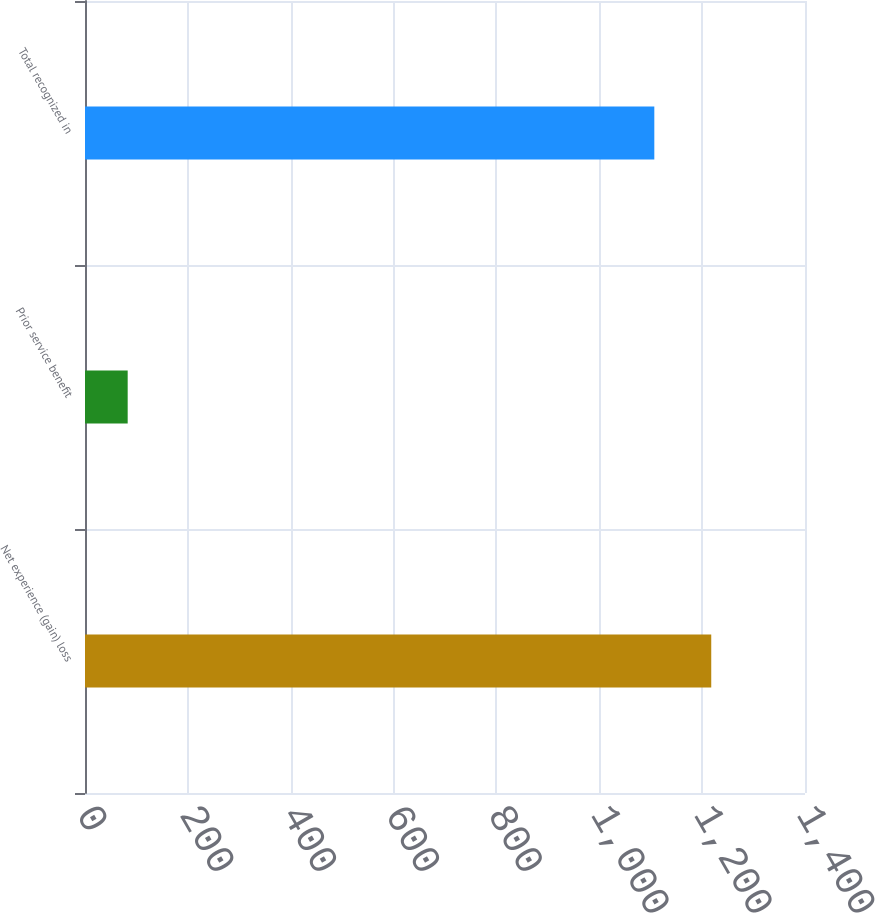<chart> <loc_0><loc_0><loc_500><loc_500><bar_chart><fcel>Net experience (gain) loss<fcel>Prior service benefit<fcel>Total recognized in<nl><fcel>1217.7<fcel>83<fcel>1107<nl></chart> 